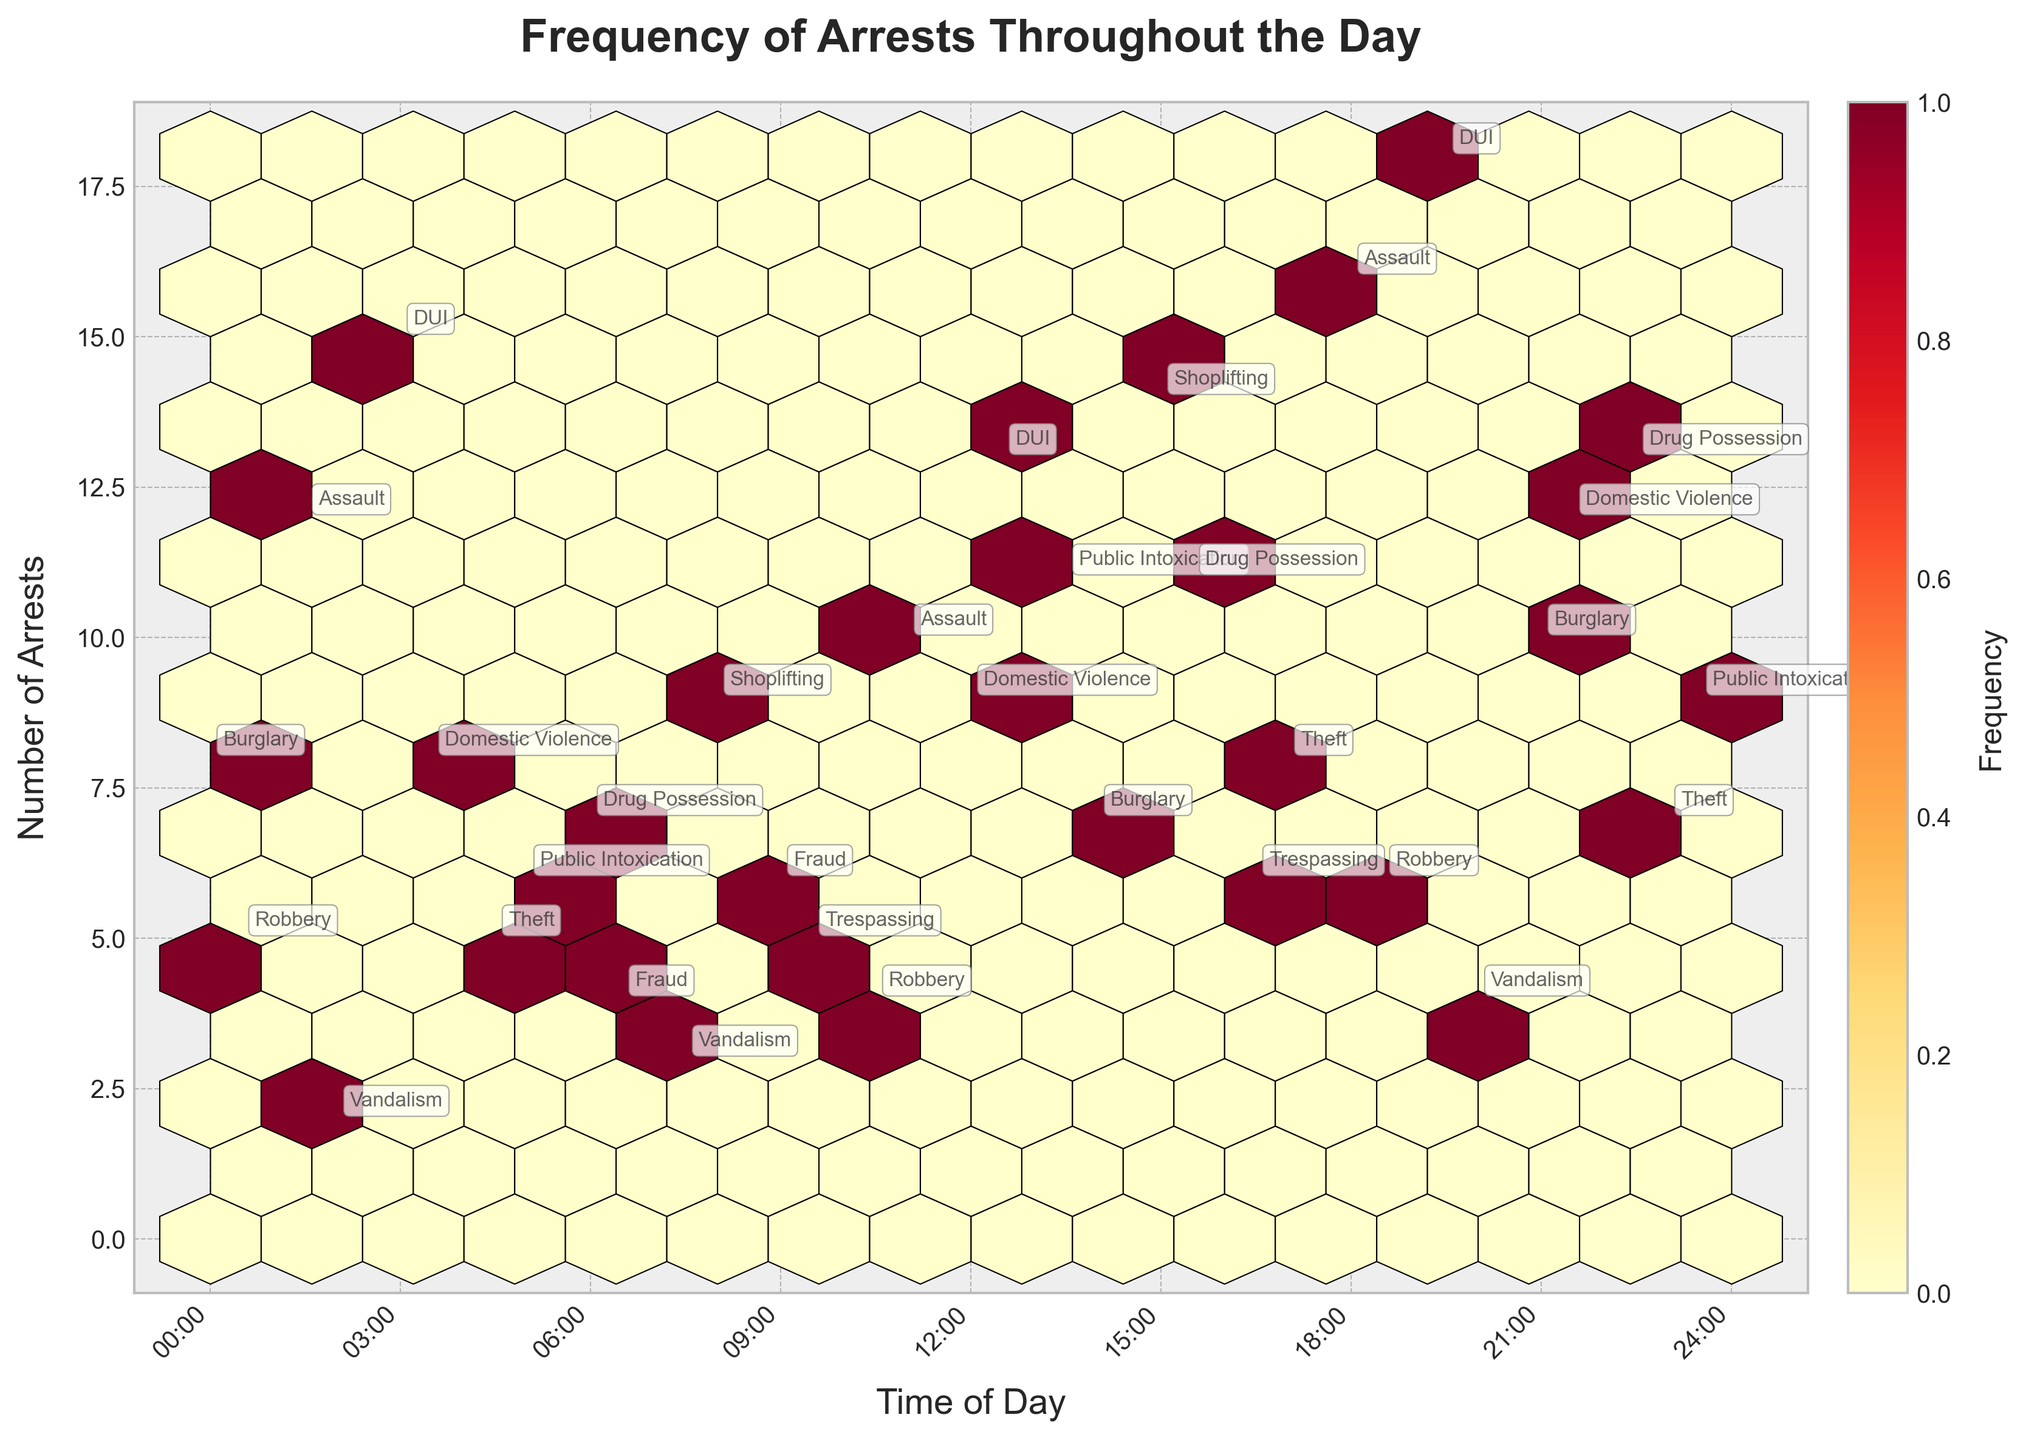What's the title of the plot? The title is displayed at the top of the figure. It provides context about what the plot is representing.
Answer: Frequency of Arrests Throughout the Day What do the x and y axes represent? The x-axis represents the 'Time of Day' and the y-axis represents the 'Number of Arrests'. This can be inferred from the axis labels.
Answer: Time of Day and Number of Arrests Which time has the highest number of arrests for DUI? Check the annotated placements for DUI in the hexbin plot and find the one with the highest arrest count. In this case, both 19:30 and 3:00 have DUI arrests. Among those, 19:30 has the highest arrest count with 18.
Answer: 19:30 How does the number of arrests for Burglary change throughout the day? Locate each occurrence of Burglary in the annotations, noting the corresponding times and arrest counts. Burglary arrests occur at 0:00 (8 arrests), 21:00 (10 arrests), and 14:00 (7 arrests). Describe the pattern or lack thereof.
Answer: Fluctuates; peak at 21:00 What is the frequency of arrests for Drug Possession between 22:00 and 23:00? Identify the time window 22:00 to 23:00 and look for Drug Possession arrests within this period. Only one significant occurrence is annotated at 22:30 with 13 arrests.
Answer: 13 arrests Which overall time period seems most active for arrests? Examine the color intensity and concentration of hexagons on the hexbin plot. More intense and denser color around a time period indicates higher arrest frequency.
Answer: Evening Compare the arrest counts for Theft at different times. Which time is higher? Theft is annotated at 4:30 (5 arrests), 23:00 (7 arrests), and 17:00 (8 arrests). Compare these values to determine the highest one.
Answer: 17:00 What do the colors and the color bar in the plot indicate? Colors represent the frequency of arrests, where a gradient is shown in the color bar ranging from lighter to darker shades, indicating lower to higher frequencies.
Answer: Frequency of arrests Which crime category has an arrest instance exactly at midnight? Identify the annotations positioned at '0:00'. The annotation shows Burglary with 8 arrests.
Answer: Burglary During what time period is there a noticeable drop-off in Public Intoxication arrests? Check the times and arrest counts for Public Intoxication. Arrests occur at 13:30 (11 arrests), 5:00 (6 arrests), and 23:30 (9 arrests). Notice the drop-off from 11 arrests at 13:30 to 6 arrests at 5:00.
Answer: Between 13:30 and 5:00 